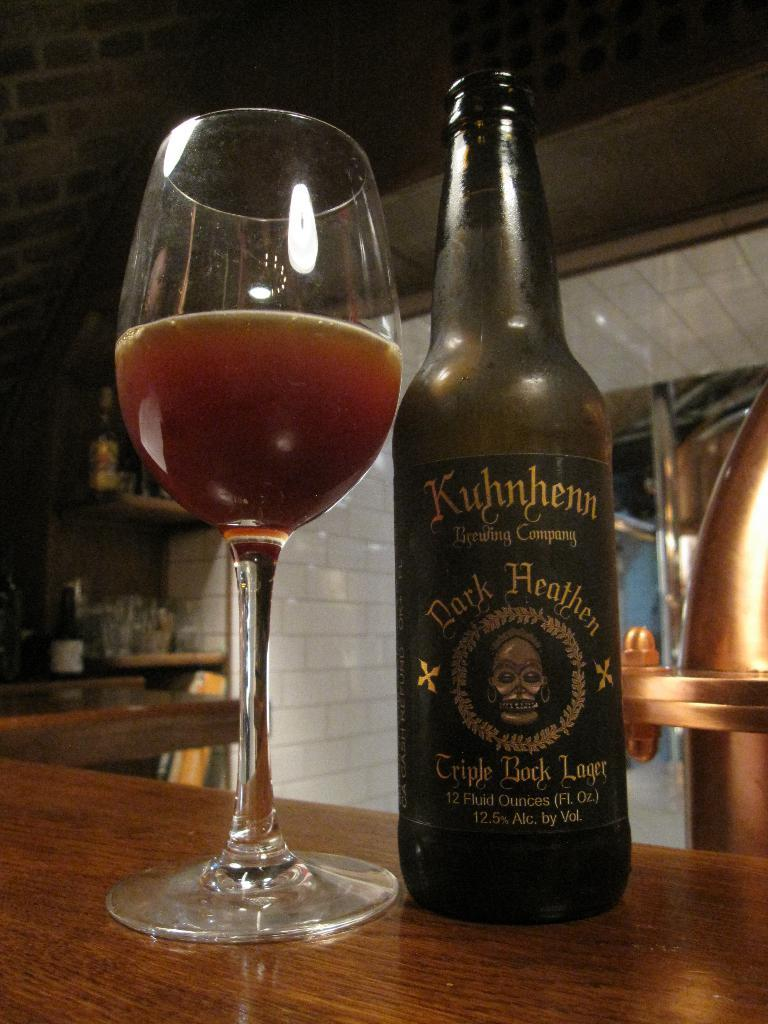What is located in the center of the image? There is a bottle and a wine glass in the center of the image. Where are the bottle and wine glass placed? Both the bottle and wine glass are placed on a table. What can be seen in the background of the image? There is a wall and a shelf in the background of the image. What type of reaction can be seen happening between the bottle and the wine glass in the image? There is no reaction happening between the bottle and the wine glass in the image; they are simply placed next to each other on the table. 